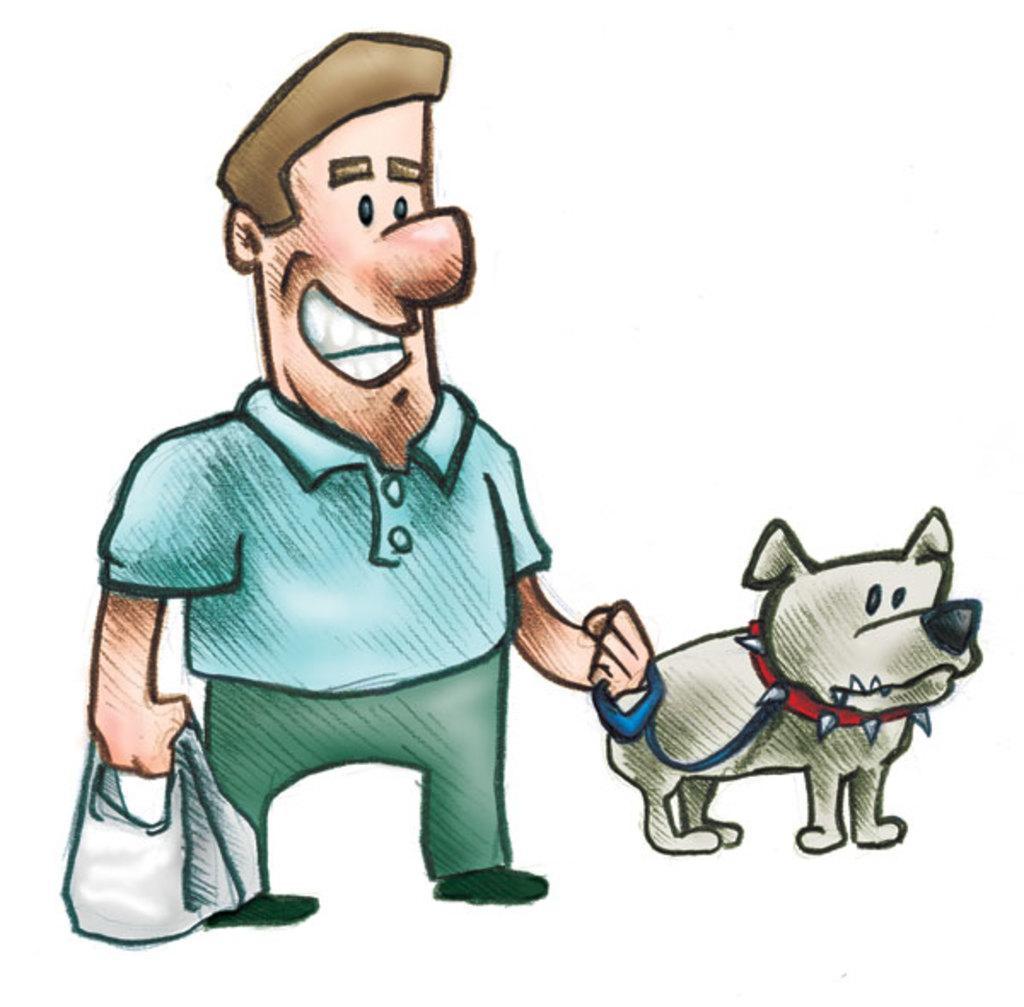Describe this image in one or two sentences. Here we can see a cartoon image, in this picture we can see a man holding a bag, on the right side there is a dog, this man is holding a strap, we can see a white color background. 